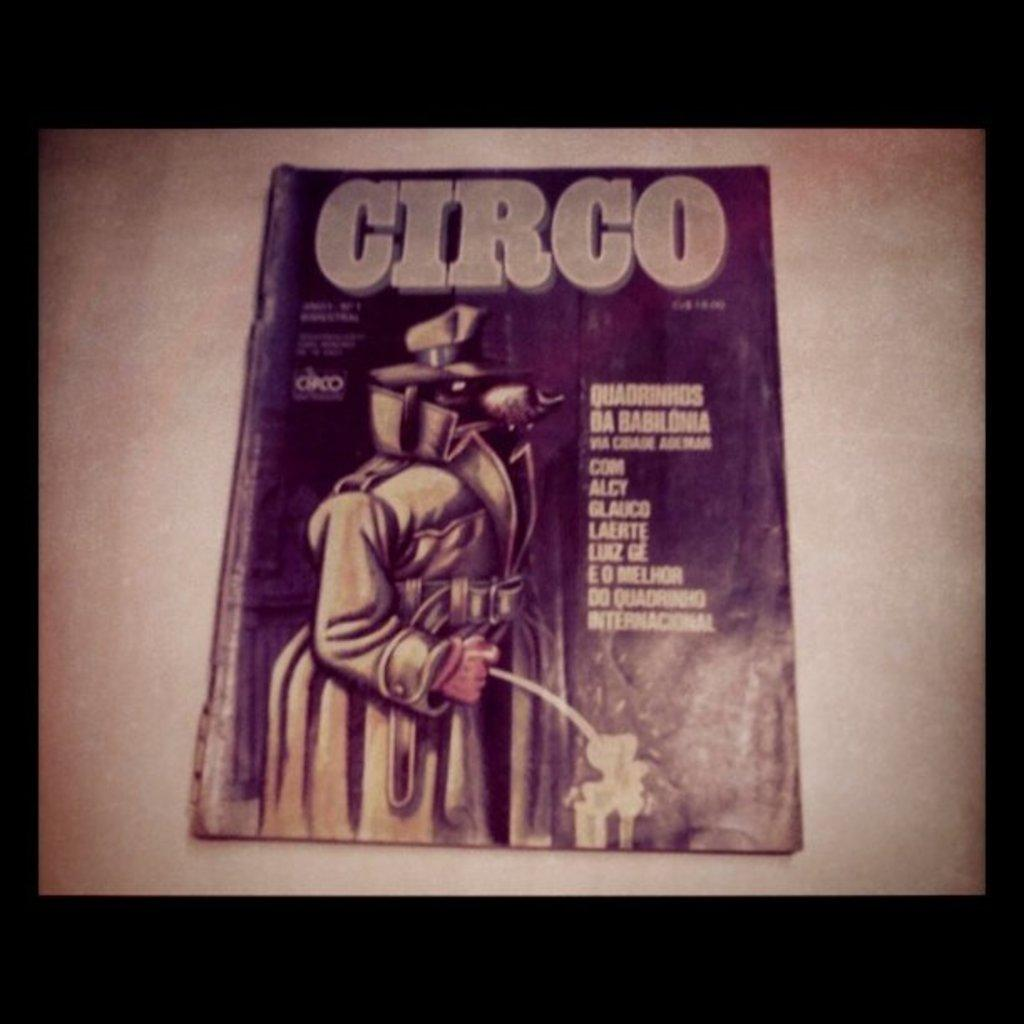<image>
Offer a succinct explanation of the picture presented. A comic book titled Circo features a cartoon detective dog on the cover. 